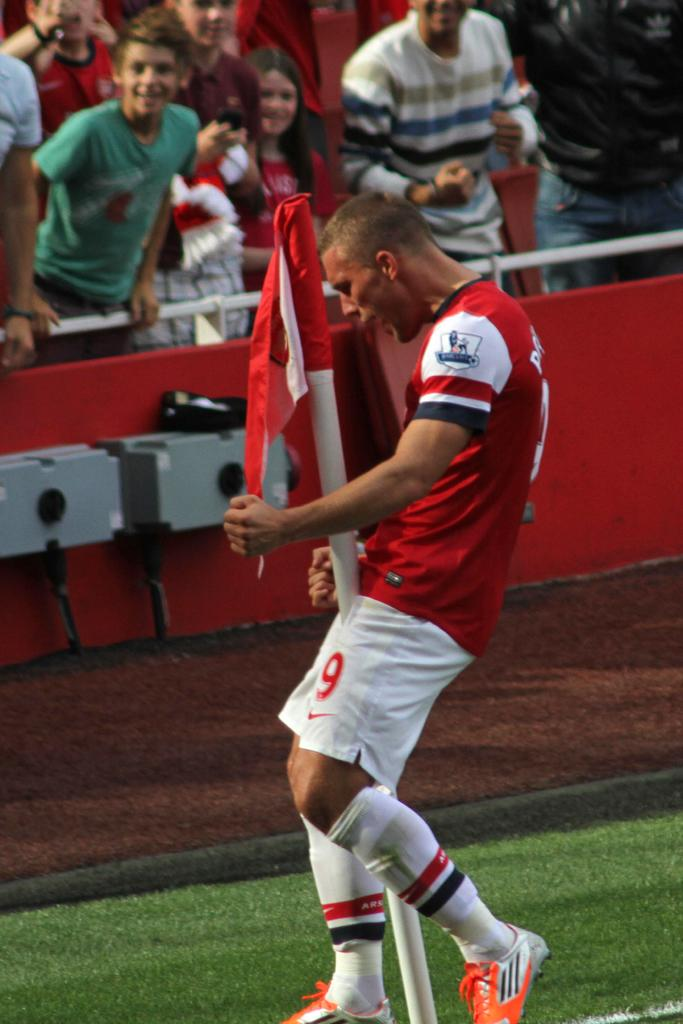<image>
Summarize the visual content of the image. An athlete has the number 9 on his shorts. 